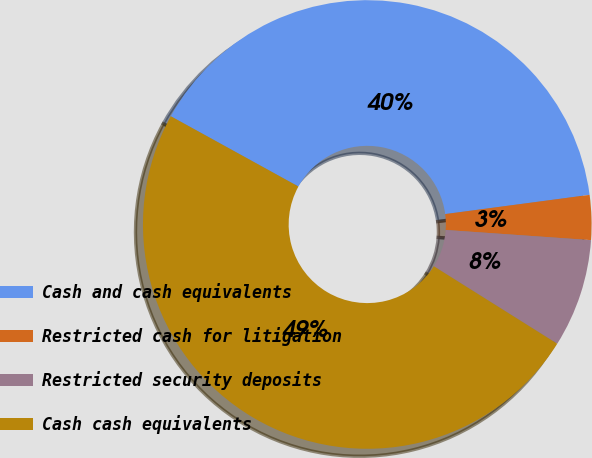Convert chart. <chart><loc_0><loc_0><loc_500><loc_500><pie_chart><fcel>Cash and cash equivalents<fcel>Restricted cash for litigation<fcel>Restricted security deposits<fcel>Cash cash equivalents<nl><fcel>39.88%<fcel>3.22%<fcel>7.81%<fcel>49.09%<nl></chart> 